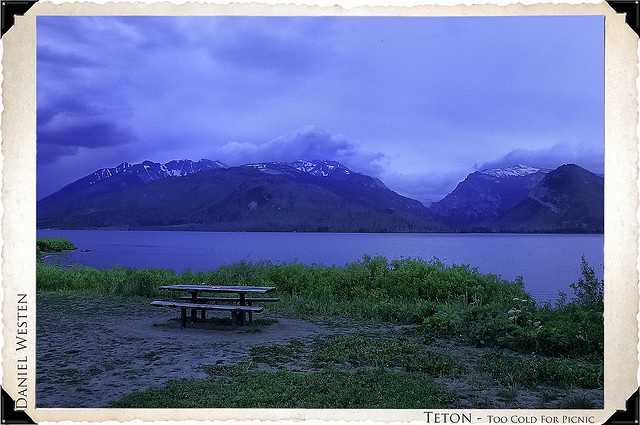Describe the objects in this image and their specific colors. I can see a dining table in darkgray, black, blue, navy, and gray tones in this image. 